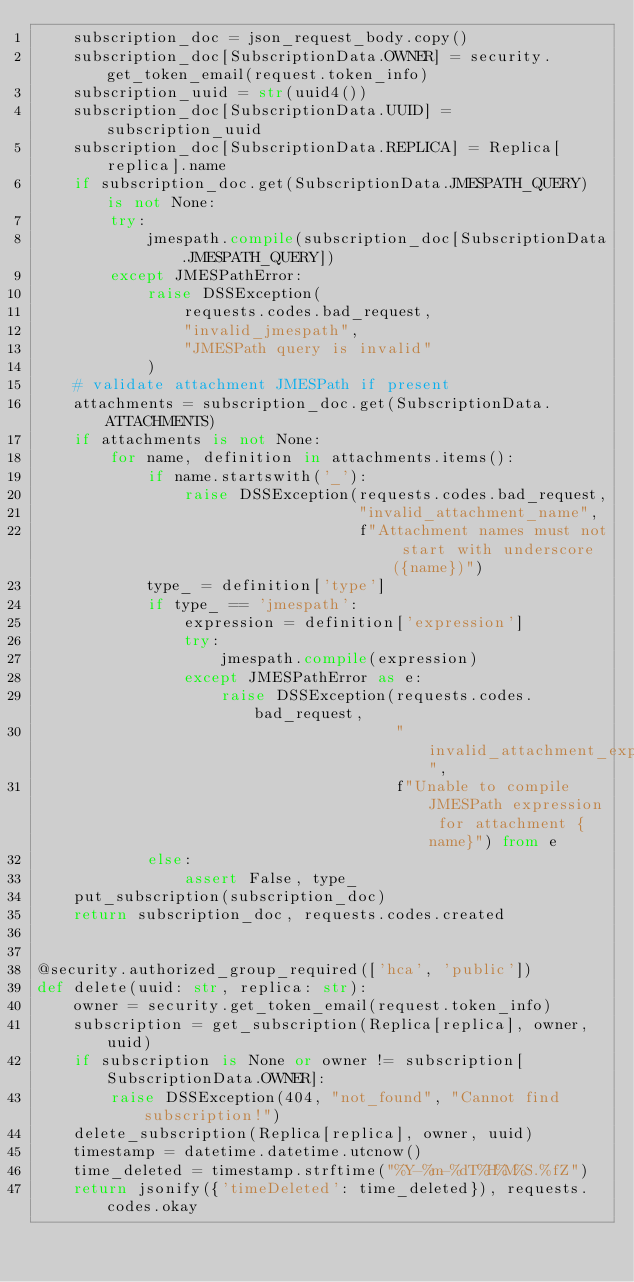<code> <loc_0><loc_0><loc_500><loc_500><_Python_>    subscription_doc = json_request_body.copy()
    subscription_doc[SubscriptionData.OWNER] = security.get_token_email(request.token_info)
    subscription_uuid = str(uuid4())
    subscription_doc[SubscriptionData.UUID] = subscription_uuid
    subscription_doc[SubscriptionData.REPLICA] = Replica[replica].name
    if subscription_doc.get(SubscriptionData.JMESPATH_QUERY) is not None:
        try:
            jmespath.compile(subscription_doc[SubscriptionData.JMESPATH_QUERY])
        except JMESPathError:
            raise DSSException(
                requests.codes.bad_request,
                "invalid_jmespath",
                "JMESPath query is invalid"
            )
    # validate attachment JMESPath if present
    attachments = subscription_doc.get(SubscriptionData.ATTACHMENTS)
    if attachments is not None:
        for name, definition in attachments.items():
            if name.startswith('_'):
                raise DSSException(requests.codes.bad_request,
                                   "invalid_attachment_name",
                                   f"Attachment names must not start with underscore ({name})")
            type_ = definition['type']
            if type_ == 'jmespath':
                expression = definition['expression']
                try:
                    jmespath.compile(expression)
                except JMESPathError as e:
                    raise DSSException(requests.codes.bad_request,
                                       "invalid_attachment_expression",
                                       f"Unable to compile JMESPath expression for attachment {name}") from e
            else:
                assert False, type_
    put_subscription(subscription_doc)
    return subscription_doc, requests.codes.created


@security.authorized_group_required(['hca', 'public'])
def delete(uuid: str, replica: str):
    owner = security.get_token_email(request.token_info)
    subscription = get_subscription(Replica[replica], owner, uuid)
    if subscription is None or owner != subscription[SubscriptionData.OWNER]:
        raise DSSException(404, "not_found", "Cannot find subscription!")
    delete_subscription(Replica[replica], owner, uuid)
    timestamp = datetime.datetime.utcnow()
    time_deleted = timestamp.strftime("%Y-%m-%dT%H%M%S.%fZ")
    return jsonify({'timeDeleted': time_deleted}), requests.codes.okay
</code> 